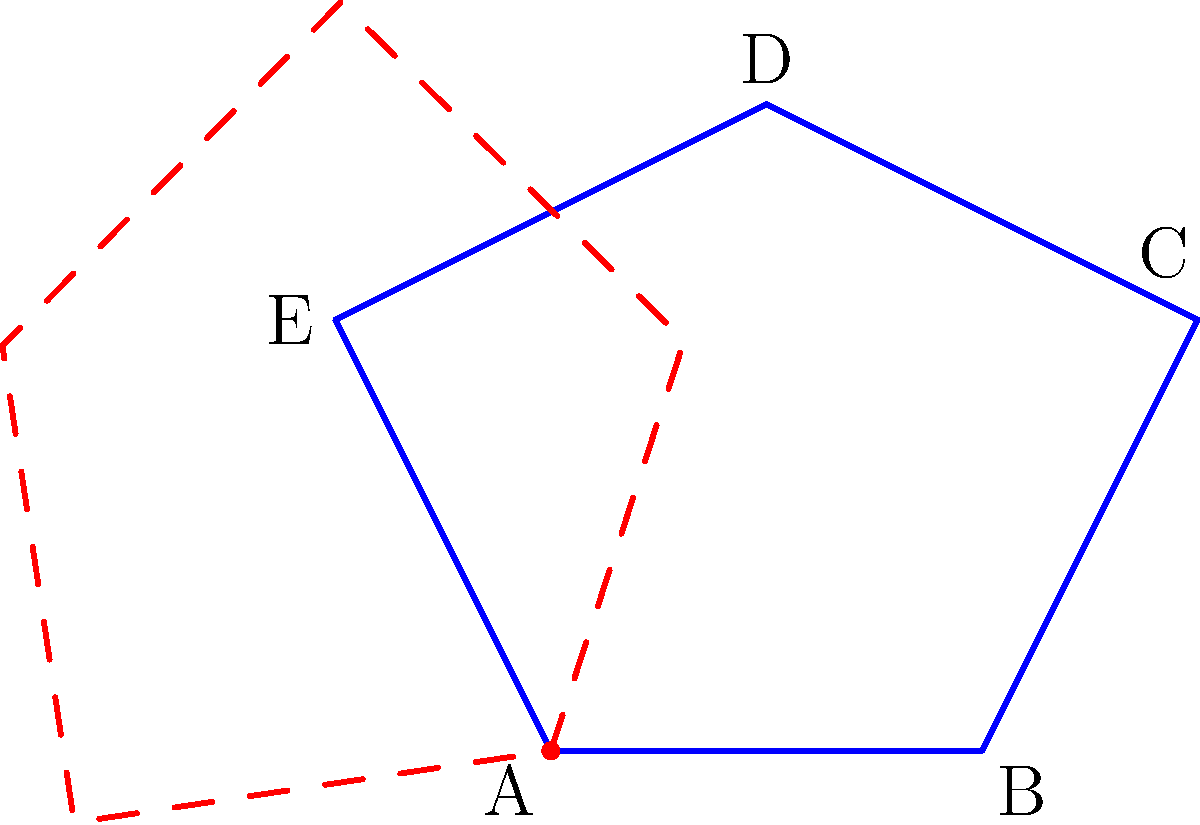Darling, feast your eyes on this dazzling gemstone-shaped polygon! If we were to rotate this beauty 72° clockwise around point A, which vertex would end up precisely where E is now? Don't let its brilliance blind you to the answer! Let's cut through the sparkle and break this down step-by-step:

1) First, we need to understand what a 72° clockwise rotation around point A means. It's like spinning the gemstone on a pivot at A, moving each point in a circular arc.

2) In a complete 360° rotation, each vertex would make a full circle. Since we're only rotating 72°, that's 1/5 of a full rotation (because $72° = 360° ÷ 5$).

3) The vertices are arranged in order A, B, C, D, E, moving counterclockwise. When we rotate clockwise, this order reverses.

4) Starting from E and moving 1/5 of the way around clockwise, we hit D. Another 1/5 brings us to C, then B, and finally A (which doesn't move as it's the center of rotation).

5) Therefore, after a 72° clockwise rotation, B will end up where E was originally.

6) We can confirm this visually: the dashed red outline shows the polygon after rotation, and indeed, B has moved to E's original position.
Answer: B 